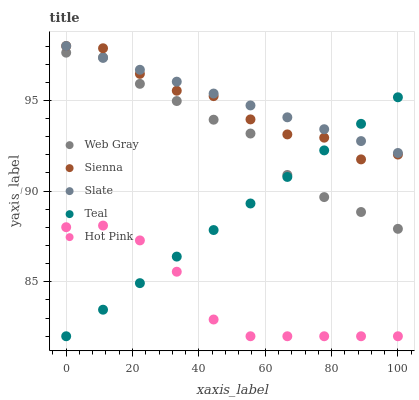Does Hot Pink have the minimum area under the curve?
Answer yes or no. Yes. Does Slate have the maximum area under the curve?
Answer yes or no. Yes. Does Web Gray have the minimum area under the curve?
Answer yes or no. No. Does Web Gray have the maximum area under the curve?
Answer yes or no. No. Is Teal the smoothest?
Answer yes or no. Yes. Is Sienna the roughest?
Answer yes or no. Yes. Is Slate the smoothest?
Answer yes or no. No. Is Slate the roughest?
Answer yes or no. No. Does Teal have the lowest value?
Answer yes or no. Yes. Does Web Gray have the lowest value?
Answer yes or no. No. Does Slate have the highest value?
Answer yes or no. Yes. Does Web Gray have the highest value?
Answer yes or no. No. Is Hot Pink less than Slate?
Answer yes or no. Yes. Is Web Gray greater than Hot Pink?
Answer yes or no. Yes. Does Sienna intersect Slate?
Answer yes or no. Yes. Is Sienna less than Slate?
Answer yes or no. No. Is Sienna greater than Slate?
Answer yes or no. No. Does Hot Pink intersect Slate?
Answer yes or no. No. 